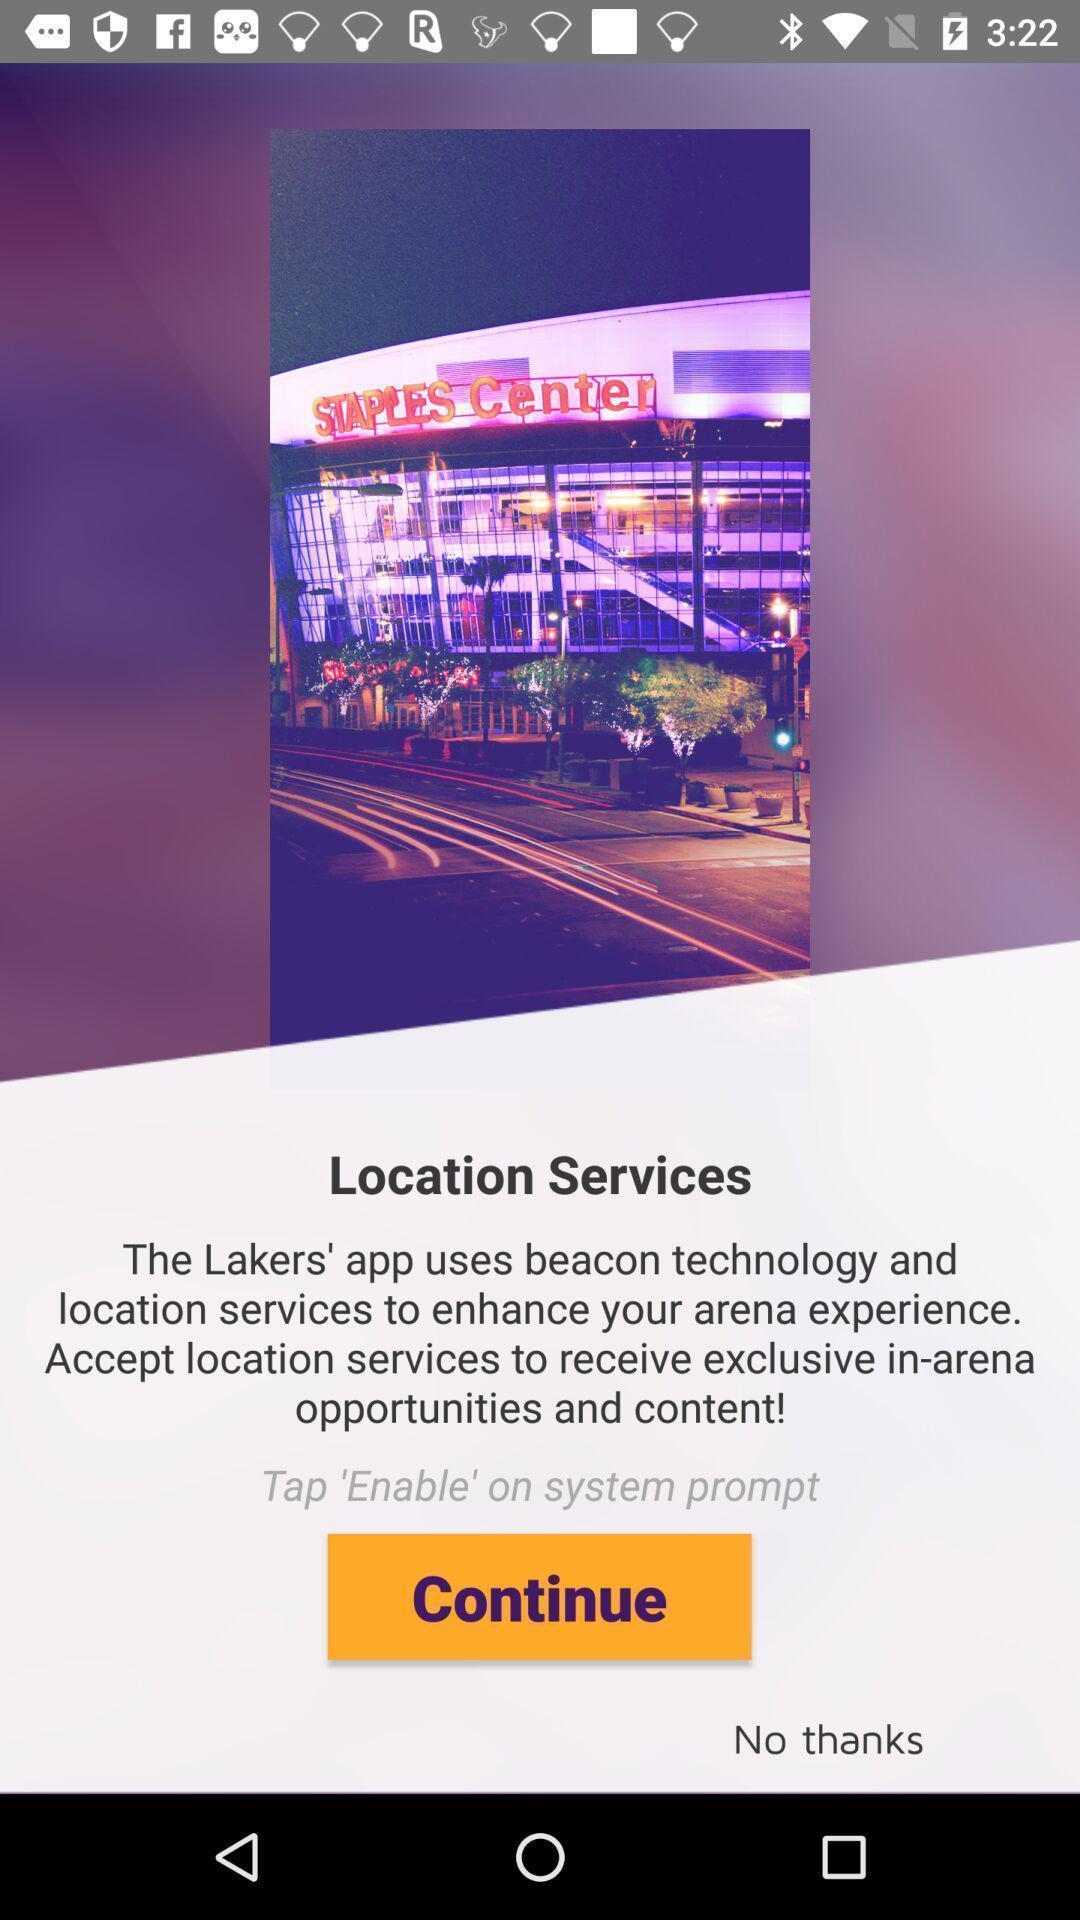Explain what's happening in this screen capture. Page for enabling location. 